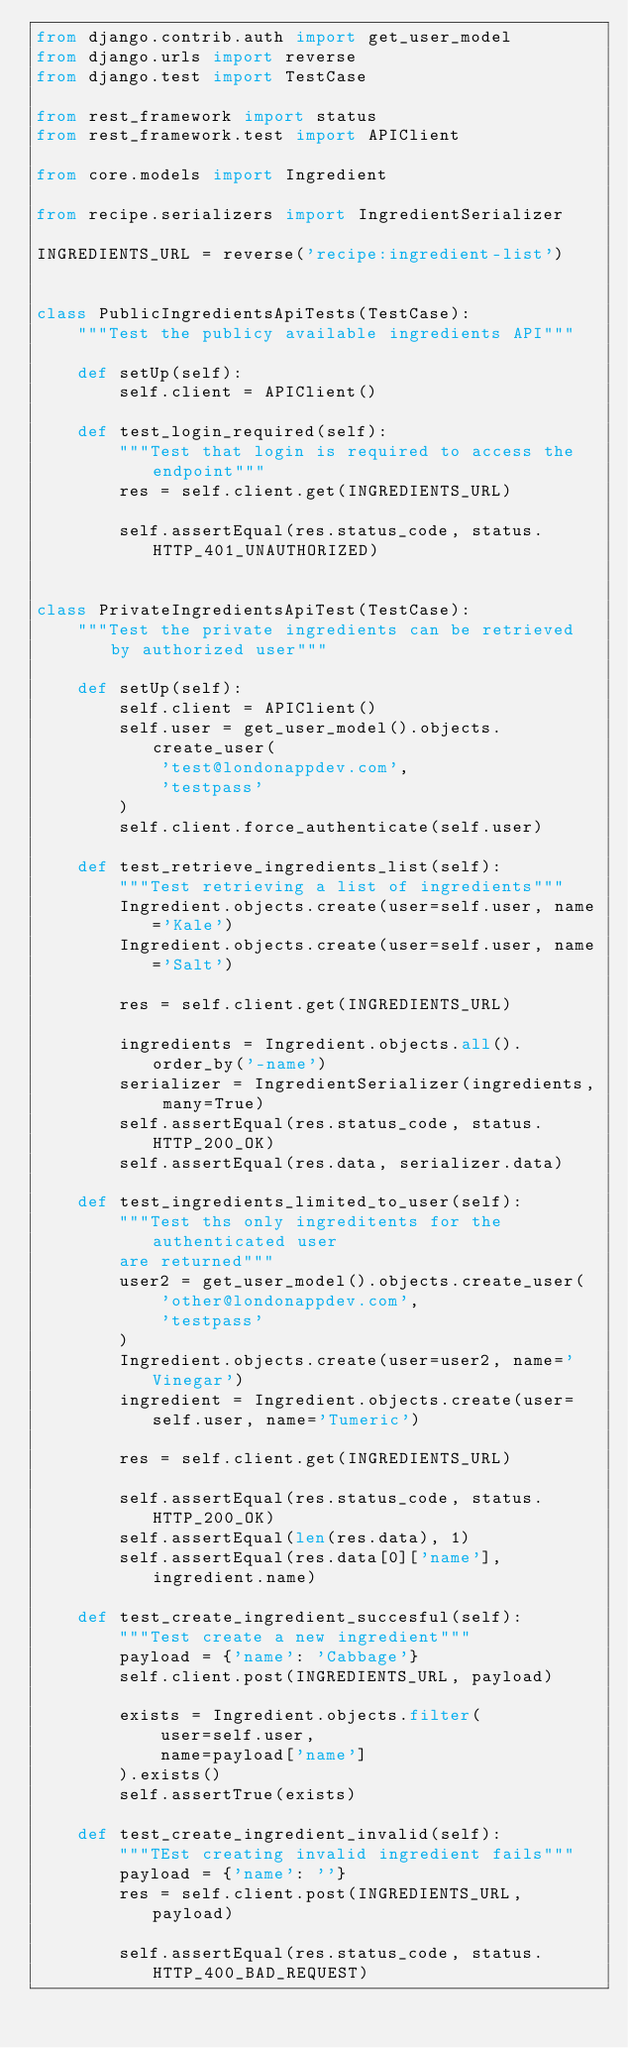Convert code to text. <code><loc_0><loc_0><loc_500><loc_500><_Python_>from django.contrib.auth import get_user_model
from django.urls import reverse
from django.test import TestCase

from rest_framework import status
from rest_framework.test import APIClient

from core.models import Ingredient

from recipe.serializers import IngredientSerializer

INGREDIENTS_URL = reverse('recipe:ingredient-list')


class PublicIngredientsApiTests(TestCase):
    """Test the publicy available ingredients API"""

    def setUp(self):
        self.client = APIClient()

    def test_login_required(self):
        """Test that login is required to access the endpoint"""
        res = self.client.get(INGREDIENTS_URL)

        self.assertEqual(res.status_code, status.HTTP_401_UNAUTHORIZED)


class PrivateIngredientsApiTest(TestCase):
    """Test the private ingredients can be retrieved by authorized user"""

    def setUp(self):
        self.client = APIClient()
        self.user = get_user_model().objects.create_user(
            'test@londonappdev.com',
            'testpass'
        )
        self.client.force_authenticate(self.user)

    def test_retrieve_ingredients_list(self):
        """Test retrieving a list of ingredients"""
        Ingredient.objects.create(user=self.user, name='Kale')
        Ingredient.objects.create(user=self.user, name='Salt')

        res = self.client.get(INGREDIENTS_URL)

        ingredients = Ingredient.objects.all().order_by('-name')
        serializer = IngredientSerializer(ingredients, many=True)
        self.assertEqual(res.status_code, status.HTTP_200_OK)
        self.assertEqual(res.data, serializer.data)

    def test_ingredients_limited_to_user(self):
        """Test ths only ingreditents for the authenticated user
        are returned"""
        user2 = get_user_model().objects.create_user(
            'other@londonappdev.com',
            'testpass'
        )
        Ingredient.objects.create(user=user2, name='Vinegar')
        ingredient = Ingredient.objects.create(user=self.user, name='Tumeric')

        res = self.client.get(INGREDIENTS_URL)

        self.assertEqual(res.status_code, status.HTTP_200_OK)
        self.assertEqual(len(res.data), 1)
        self.assertEqual(res.data[0]['name'], ingredient.name)

    def test_create_ingredient_succesful(self):
        """Test create a new ingredient"""
        payload = {'name': 'Cabbage'}
        self.client.post(INGREDIENTS_URL, payload)

        exists = Ingredient.objects.filter(
            user=self.user,
            name=payload['name']
        ).exists()
        self.assertTrue(exists)

    def test_create_ingredient_invalid(self):
        """TEst creating invalid ingredient fails"""
        payload = {'name': ''}
        res = self.client.post(INGREDIENTS_URL, payload)

        self.assertEqual(res.status_code, status.HTTP_400_BAD_REQUEST)
</code> 